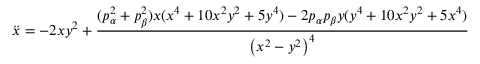<formula> <loc_0><loc_0><loc_500><loc_500>\ddot { x } = - 2 x y ^ { 2 } + { \frac { ( p _ { \alpha } ^ { 2 } + p _ { \beta } ^ { 2 } ) x ( x ^ { 4 } + 1 0 x ^ { 2 } y ^ { 2 } + 5 y ^ { 4 } ) - 2 p _ { \alpha } p _ { \beta } y ( y ^ { 4 } + 1 0 x ^ { 2 } y ^ { 2 } + 5 x ^ { 4 } ) } { \left ( x ^ { 2 } - y ^ { 2 } \right ) ^ { 4 } } }</formula> 